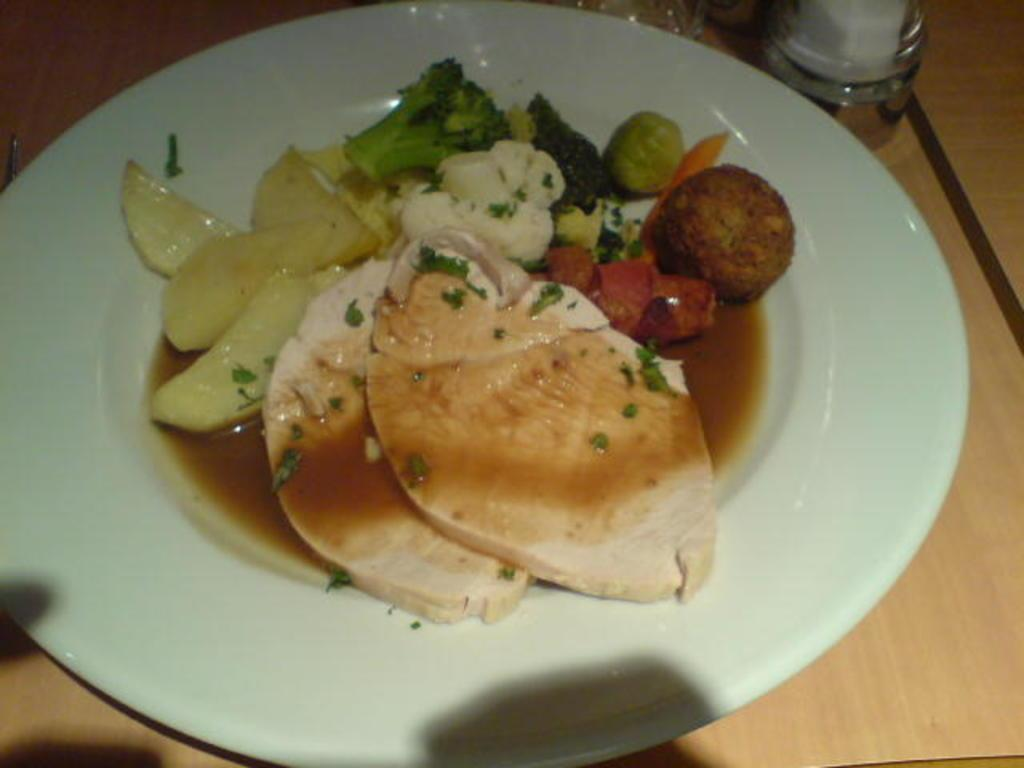What type of table is in the image? There is a wooden table in the image. What is on the table? There is a plate and a glass on the table. What is on the plate? The plate contains meat and vegetable salad. What accompanies the vegetable salad on the plate? There is sauce on the vegetable salad. Where is the kettle located in the image? There is no kettle present in the image. What type of mint is used in the vegetable salad? There is no mention of mint in the image or the provided facts. 